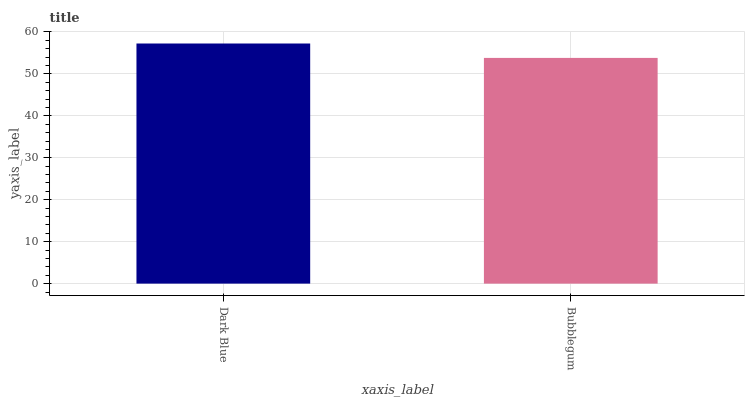Is Bubblegum the minimum?
Answer yes or no. Yes. Is Dark Blue the maximum?
Answer yes or no. Yes. Is Bubblegum the maximum?
Answer yes or no. No. Is Dark Blue greater than Bubblegum?
Answer yes or no. Yes. Is Bubblegum less than Dark Blue?
Answer yes or no. Yes. Is Bubblegum greater than Dark Blue?
Answer yes or no. No. Is Dark Blue less than Bubblegum?
Answer yes or no. No. Is Dark Blue the high median?
Answer yes or no. Yes. Is Bubblegum the low median?
Answer yes or no. Yes. Is Bubblegum the high median?
Answer yes or no. No. Is Dark Blue the low median?
Answer yes or no. No. 